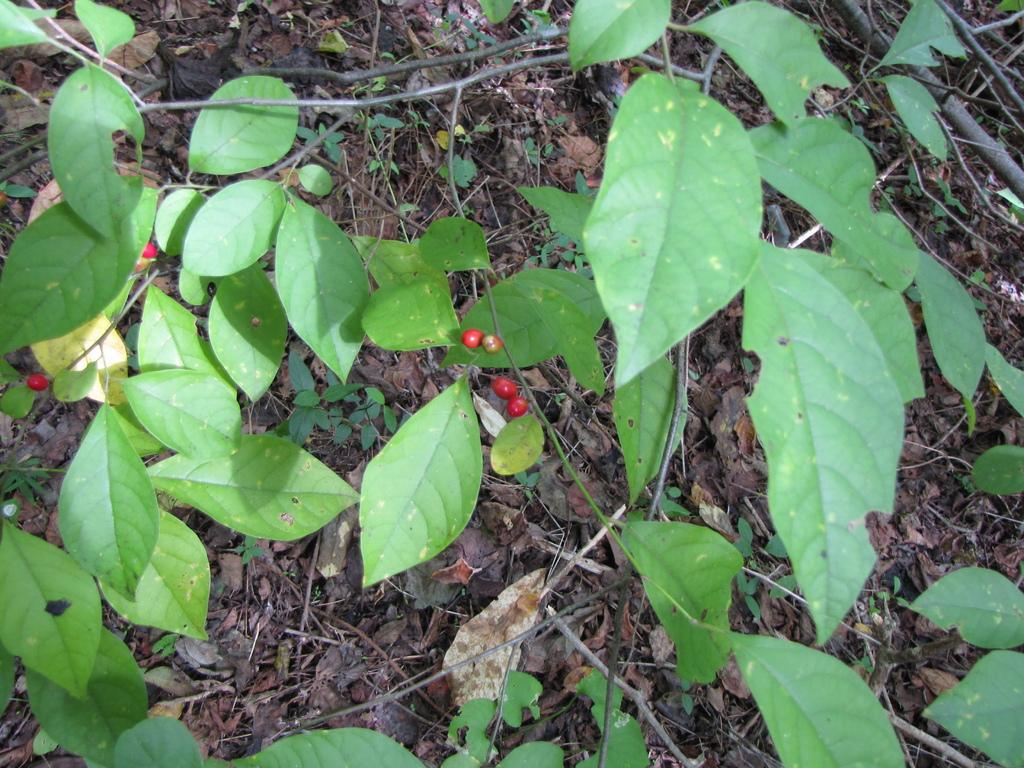What type of vegetation can be seen in the image? There are plant leaves in the image. What else can be seen on the plant in the image? There are fruits visible on the plant in the image. Where is the person reading a book in the library in the image? There is no person reading a book in the library in the image; it only features plant leaves and fruits. 